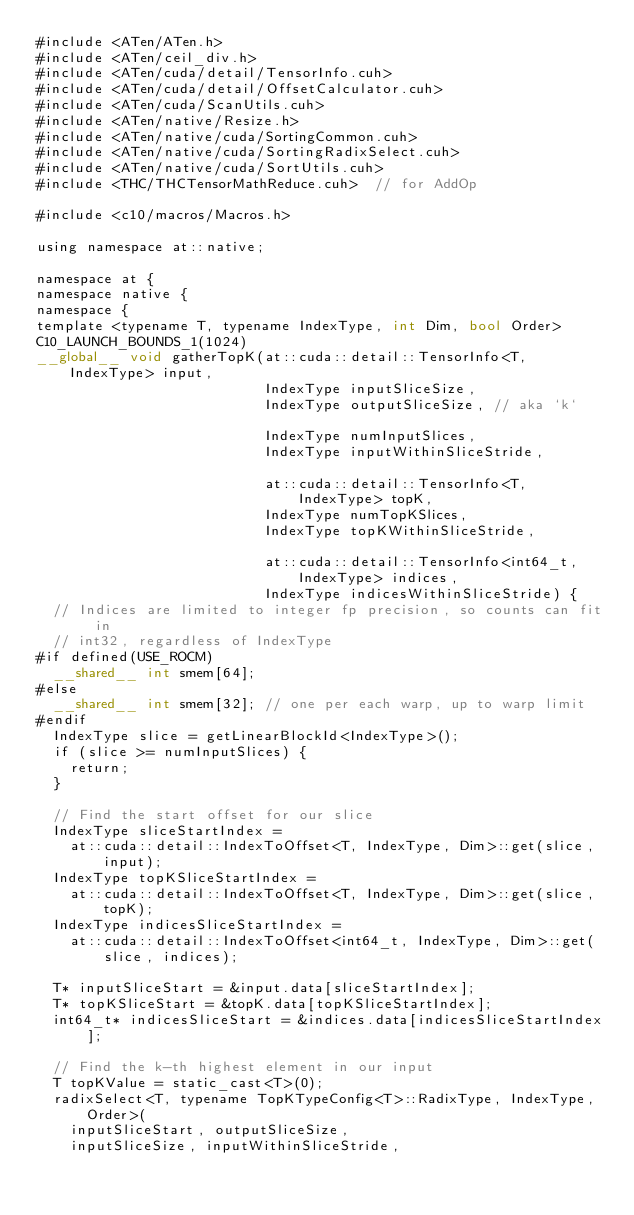Convert code to text. <code><loc_0><loc_0><loc_500><loc_500><_Cuda_>#include <ATen/ATen.h>
#include <ATen/ceil_div.h>
#include <ATen/cuda/detail/TensorInfo.cuh>
#include <ATen/cuda/detail/OffsetCalculator.cuh>
#include <ATen/cuda/ScanUtils.cuh>
#include <ATen/native/Resize.h>
#include <ATen/native/cuda/SortingCommon.cuh>
#include <ATen/native/cuda/SortingRadixSelect.cuh>
#include <ATen/native/cuda/SortUtils.cuh>
#include <THC/THCTensorMathReduce.cuh>  // for AddOp

#include <c10/macros/Macros.h>

using namespace at::native;

namespace at {
namespace native {
namespace {
template <typename T, typename IndexType, int Dim, bool Order>
C10_LAUNCH_BOUNDS_1(1024)
__global__ void gatherTopK(at::cuda::detail::TensorInfo<T, IndexType> input,
                           IndexType inputSliceSize,
                           IndexType outputSliceSize, // aka `k`

                           IndexType numInputSlices,
                           IndexType inputWithinSliceStride,

                           at::cuda::detail::TensorInfo<T, IndexType> topK,
                           IndexType numTopKSlices,
                           IndexType topKWithinSliceStride,

                           at::cuda::detail::TensorInfo<int64_t, IndexType> indices,
                           IndexType indicesWithinSliceStride) {
  // Indices are limited to integer fp precision, so counts can fit in
  // int32, regardless of IndexType
#if defined(USE_ROCM)
  __shared__ int smem[64];
#else
  __shared__ int smem[32]; // one per each warp, up to warp limit
#endif
  IndexType slice = getLinearBlockId<IndexType>();
  if (slice >= numInputSlices) {
    return;
  }

  // Find the start offset for our slice
  IndexType sliceStartIndex =
    at::cuda::detail::IndexToOffset<T, IndexType, Dim>::get(slice, input);
  IndexType topKSliceStartIndex =
    at::cuda::detail::IndexToOffset<T, IndexType, Dim>::get(slice, topK);
  IndexType indicesSliceStartIndex =
    at::cuda::detail::IndexToOffset<int64_t, IndexType, Dim>::get(slice, indices);

  T* inputSliceStart = &input.data[sliceStartIndex];
  T* topKSliceStart = &topK.data[topKSliceStartIndex];
  int64_t* indicesSliceStart = &indices.data[indicesSliceStartIndex];

  // Find the k-th highest element in our input
  T topKValue = static_cast<T>(0);
  radixSelect<T, typename TopKTypeConfig<T>::RadixType, IndexType, Order>(
    inputSliceStart, outputSliceSize,
    inputSliceSize, inputWithinSliceStride,</code> 